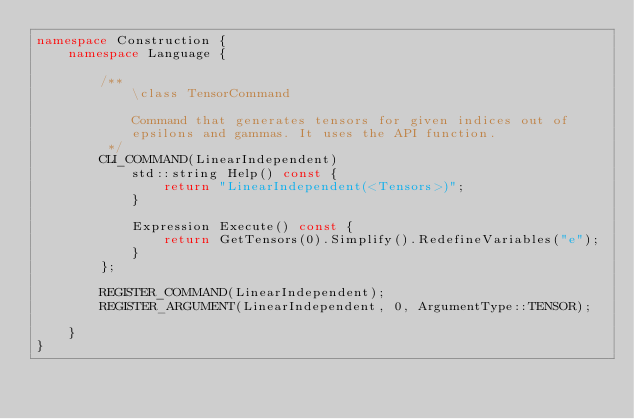<code> <loc_0><loc_0><loc_500><loc_500><_C++_>namespace Construction {
    namespace Language {

        /**
            \class TensorCommand

            Command that generates tensors for given indices out of
            epsilons and gammas. It uses the API function.
         */
        CLI_COMMAND(LinearIndependent)
            std::string Help() const {
                return "LinearIndependent(<Tensors>)";
            }

            Expression Execute() const {
                return GetTensors(0).Simplify().RedefineVariables("e");
            }
        };

        REGISTER_COMMAND(LinearIndependent);
        REGISTER_ARGUMENT(LinearIndependent, 0, ArgumentType::TENSOR);

    }
}</code> 